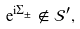Convert formula to latex. <formula><loc_0><loc_0><loc_500><loc_500>\mathrm e ^ { \mathrm i \Sigma _ { \pm } } \notin \mathcal { S } ^ { \prime } ,</formula> 